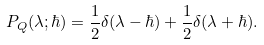<formula> <loc_0><loc_0><loc_500><loc_500>P _ { Q } ( \lambda ; \hbar { ) } = \frac { 1 } { 2 } \delta ( \lambda - \hbar { ) } + \frac { 1 } { 2 } \delta ( \lambda + \hbar { ) } .</formula> 